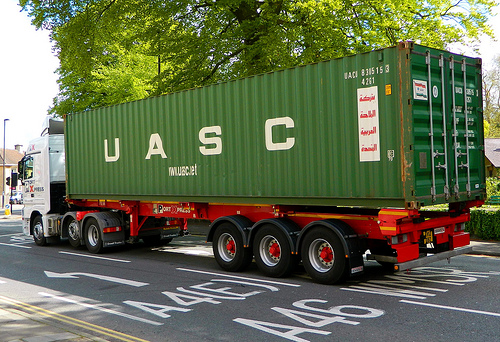Is the green vehicle to the left or to the right of the house? The green vehicle is to the left of the house. 